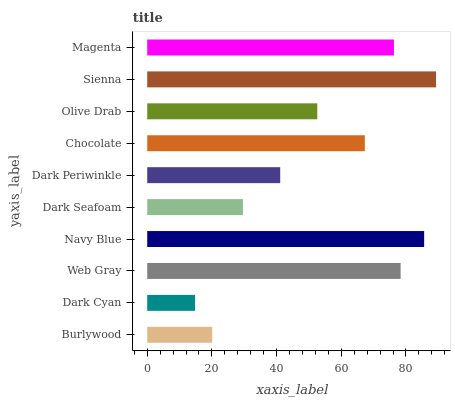Is Dark Cyan the minimum?
Answer yes or no. Yes. Is Sienna the maximum?
Answer yes or no. Yes. Is Web Gray the minimum?
Answer yes or no. No. Is Web Gray the maximum?
Answer yes or no. No. Is Web Gray greater than Dark Cyan?
Answer yes or no. Yes. Is Dark Cyan less than Web Gray?
Answer yes or no. Yes. Is Dark Cyan greater than Web Gray?
Answer yes or no. No. Is Web Gray less than Dark Cyan?
Answer yes or no. No. Is Chocolate the high median?
Answer yes or no. Yes. Is Olive Drab the low median?
Answer yes or no. Yes. Is Olive Drab the high median?
Answer yes or no. No. Is Dark Periwinkle the low median?
Answer yes or no. No. 